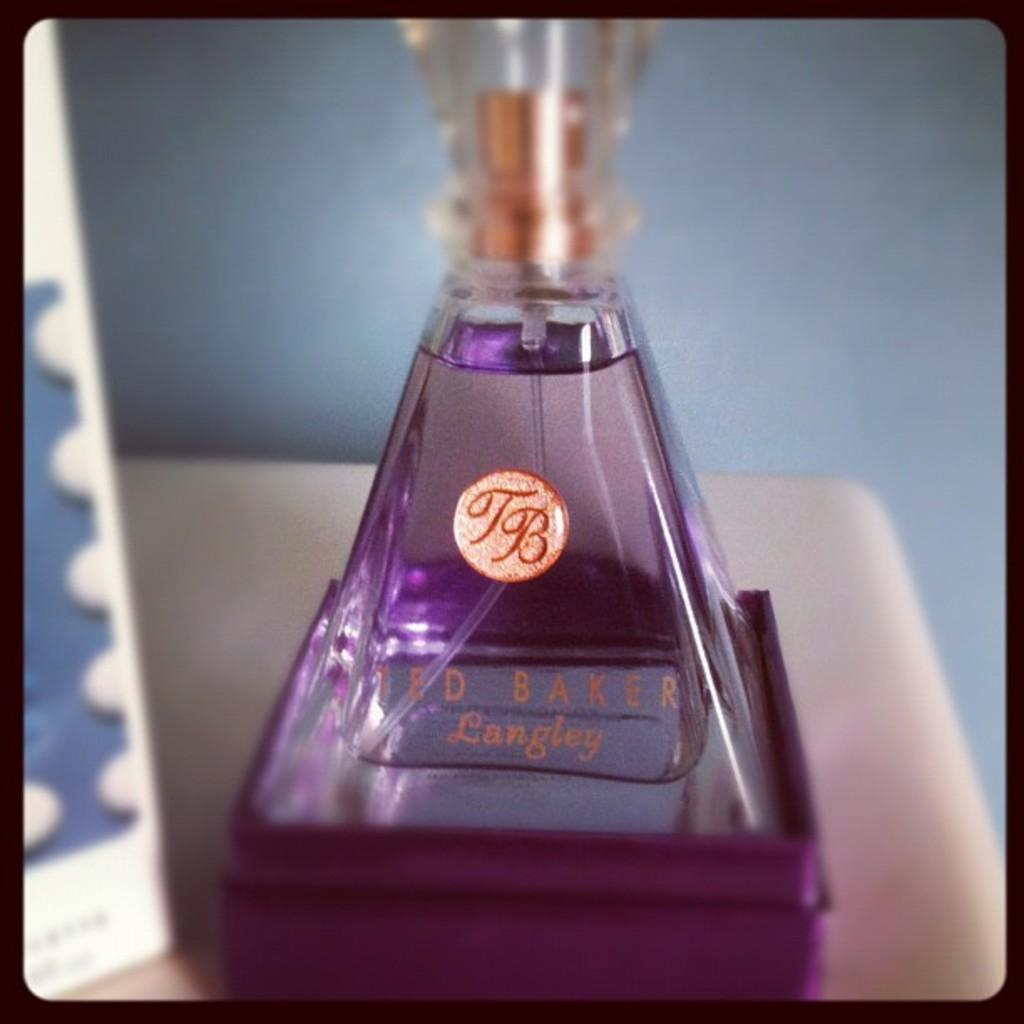<image>
Describe the image concisely. A bottle of Ted Baker perfume is in a box. 